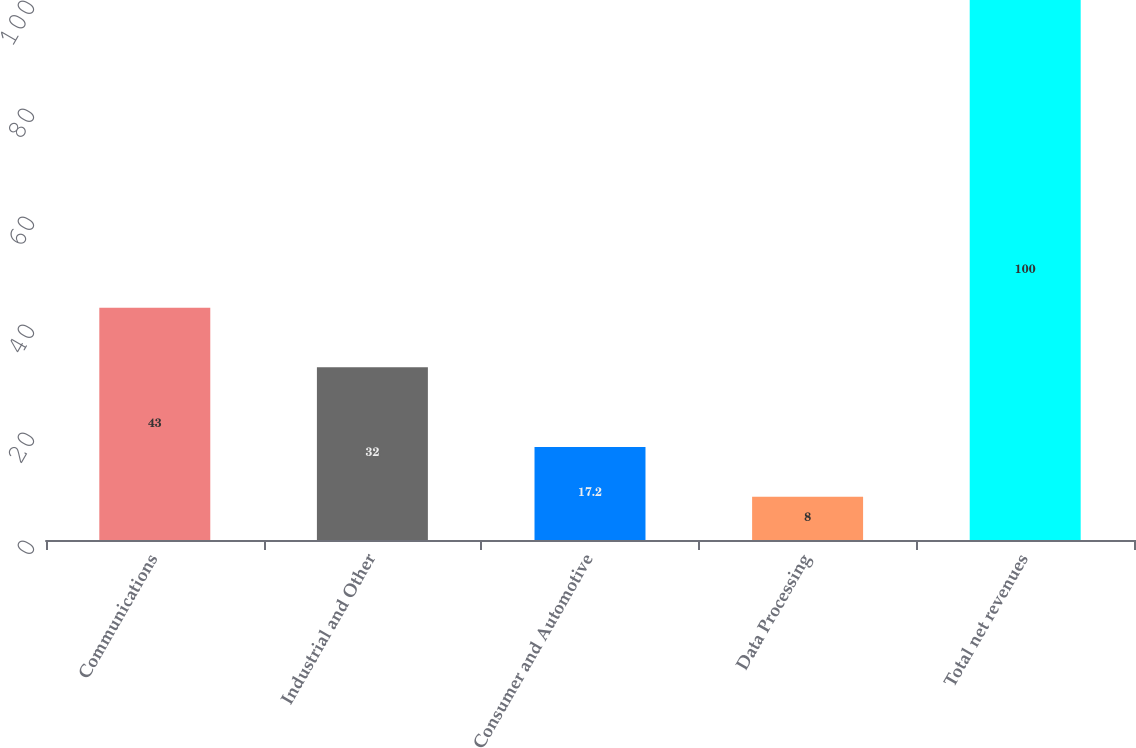Convert chart. <chart><loc_0><loc_0><loc_500><loc_500><bar_chart><fcel>Communications<fcel>Industrial and Other<fcel>Consumer and Automotive<fcel>Data Processing<fcel>Total net revenues<nl><fcel>43<fcel>32<fcel>17.2<fcel>8<fcel>100<nl></chart> 